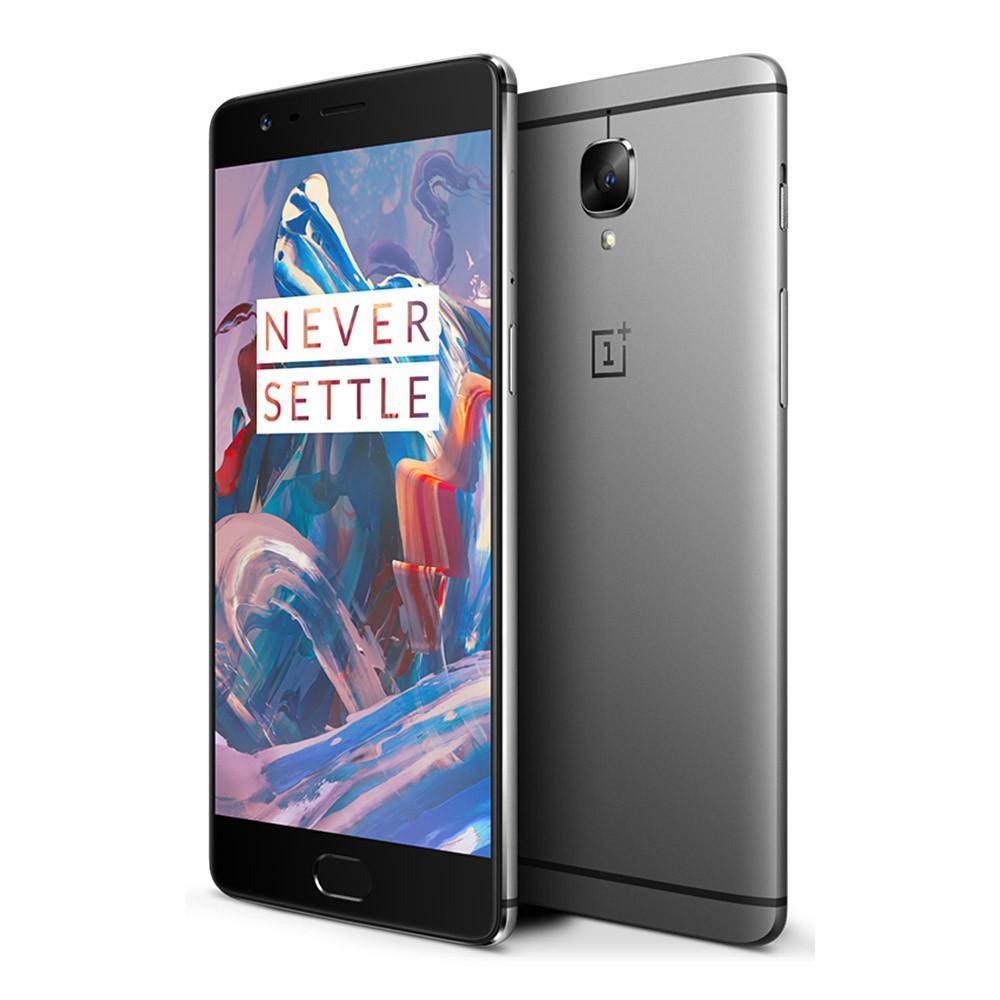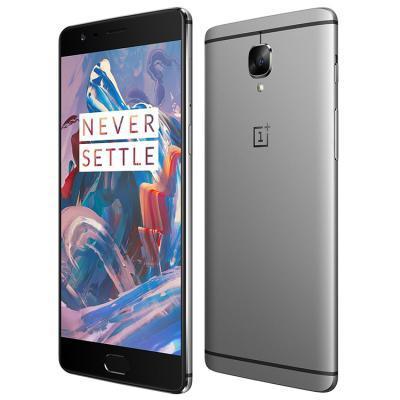The first image is the image on the left, the second image is the image on the right. Assess this claim about the two images: "The left and right image contains the same number of phones with the front side parallel with the back of the other phone.". Correct or not? Answer yes or no. Yes. 